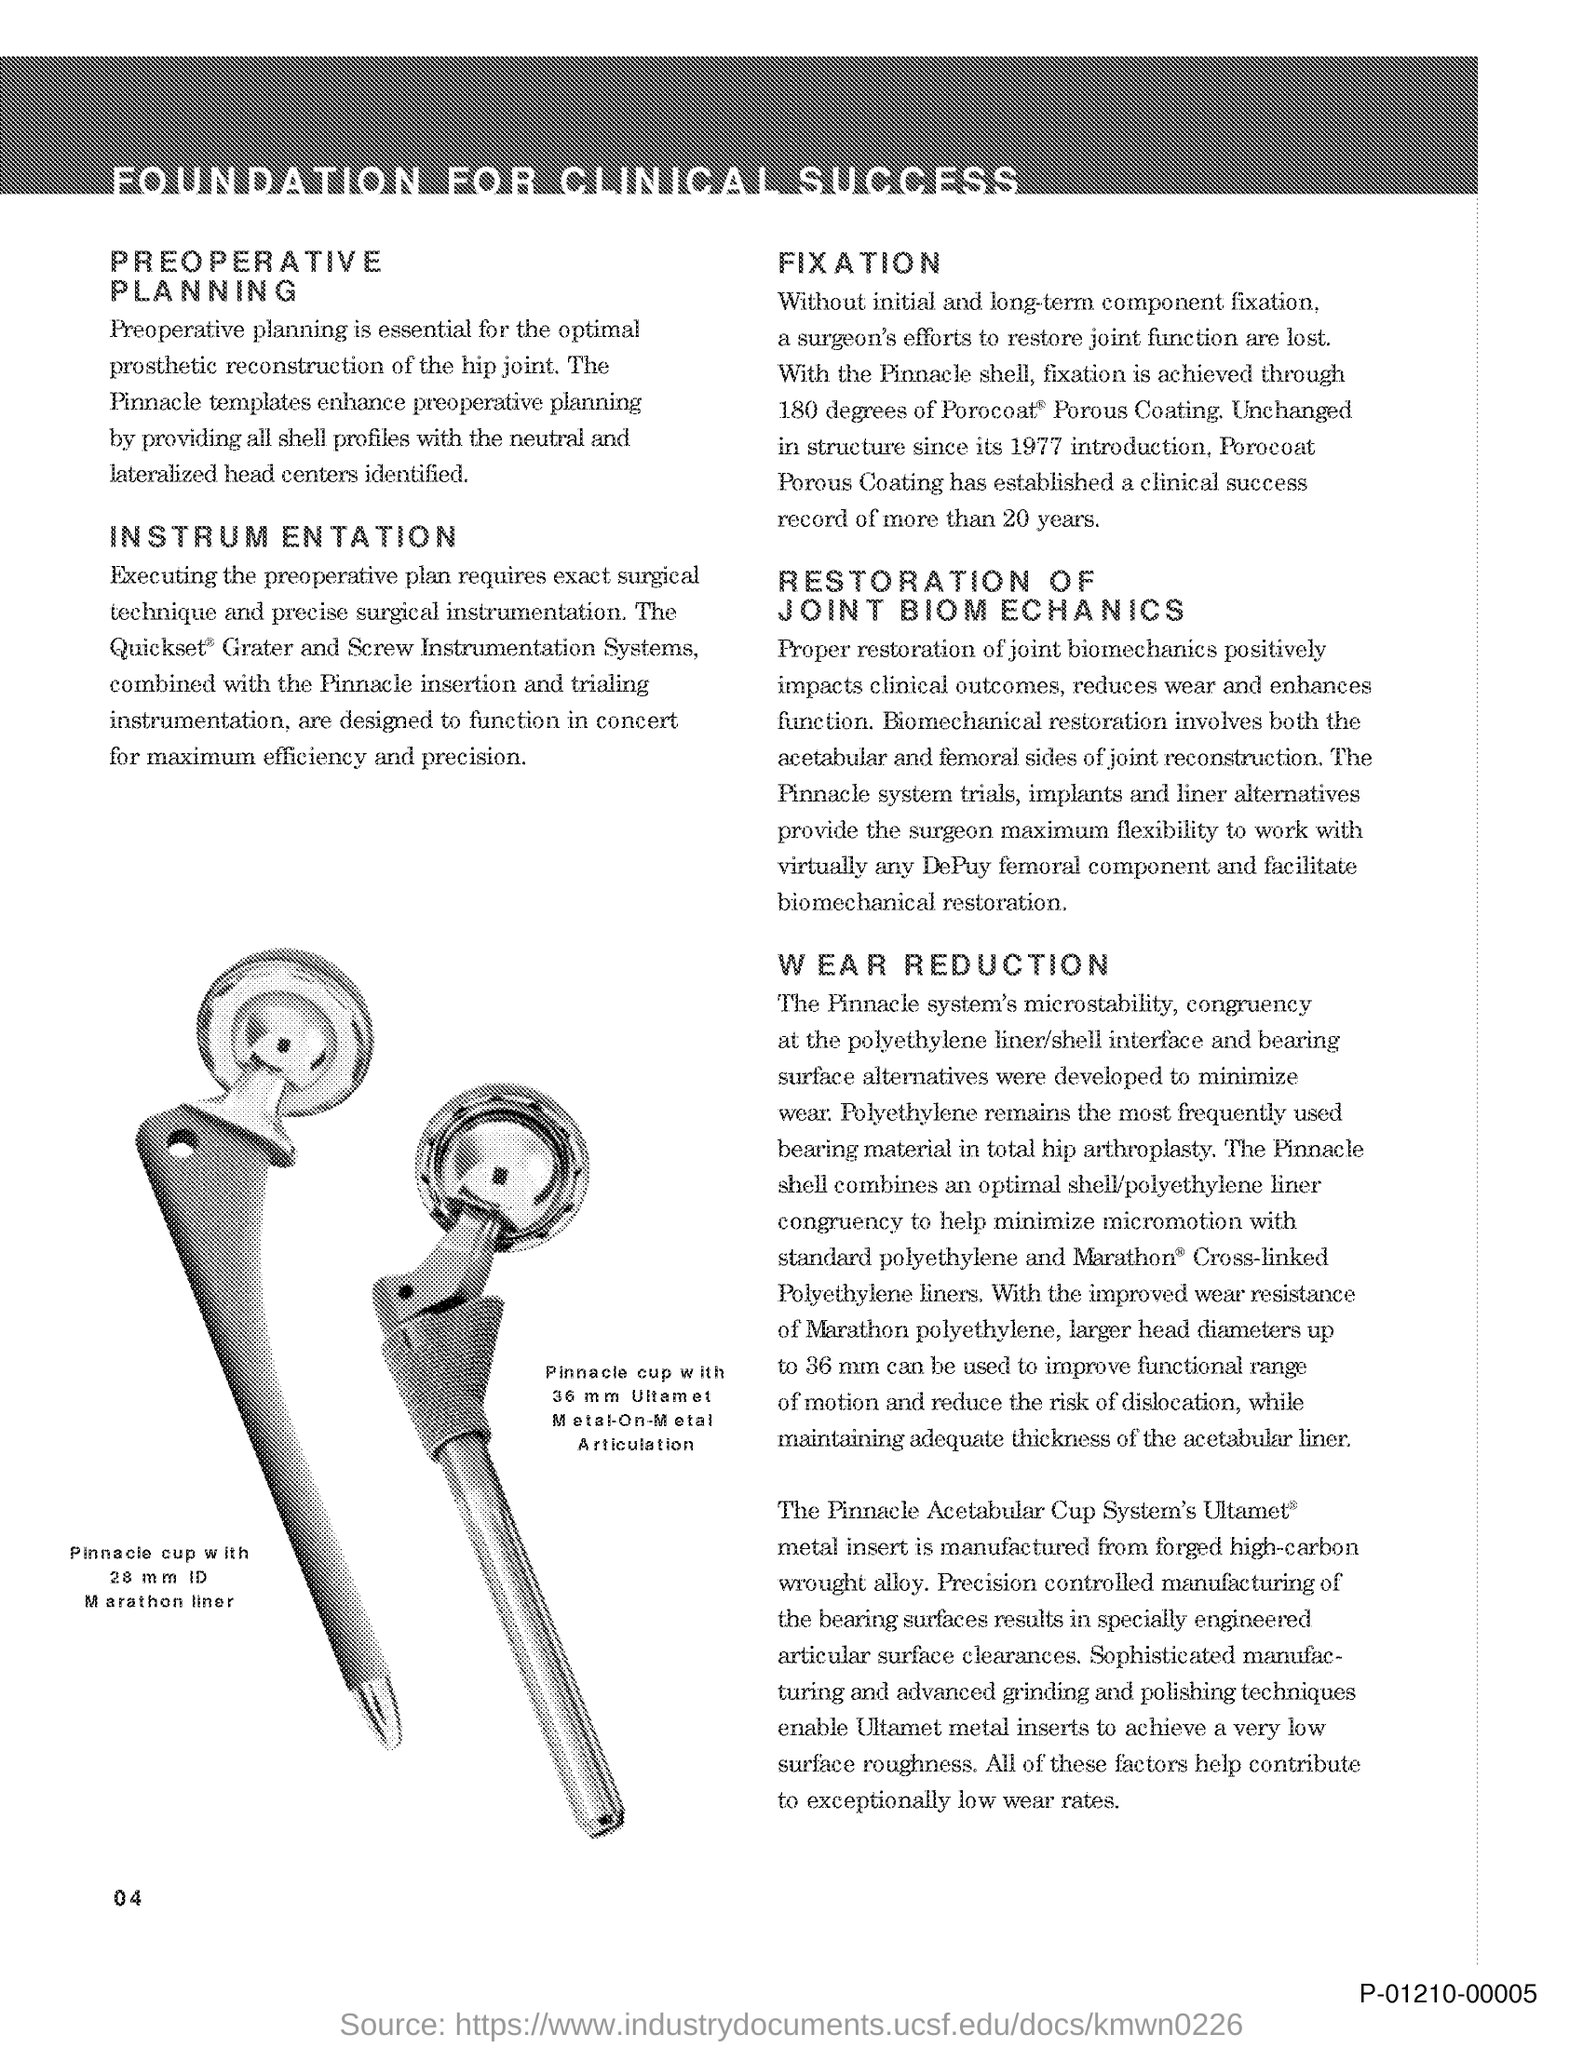Identify some key points in this picture. The title of the document is "Foundation for Clinical Success. The page number is 04. 